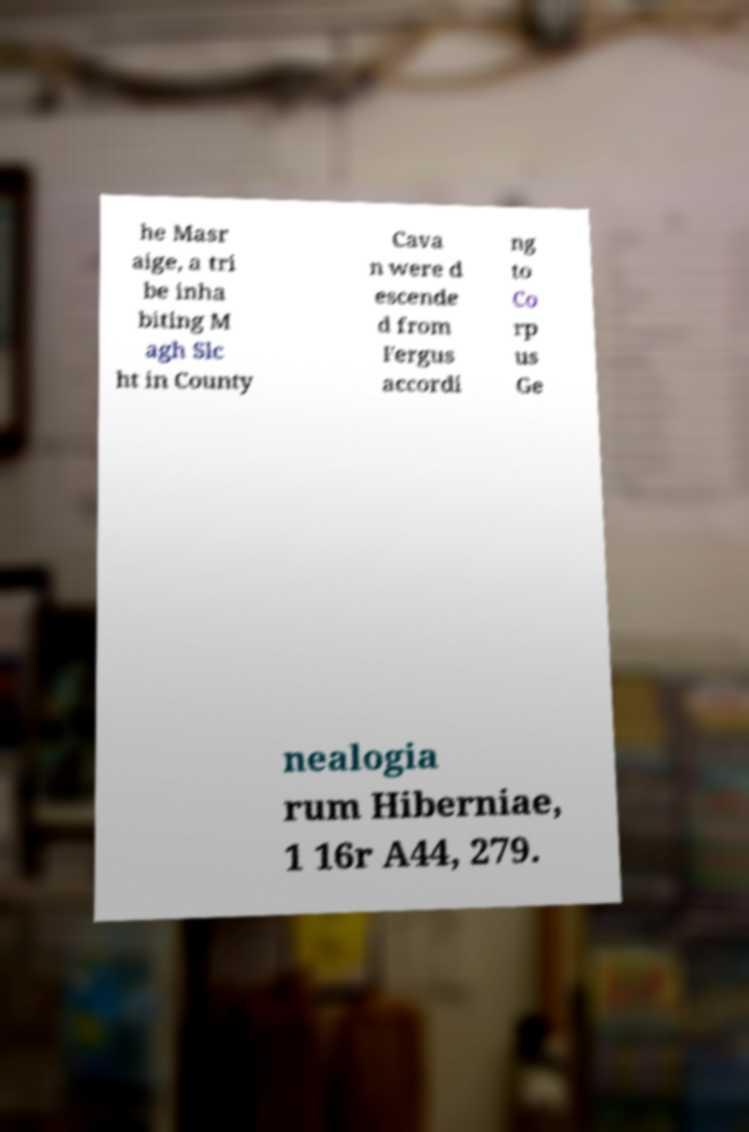Could you extract and type out the text from this image? he Masr aige, a tri be inha biting M agh Slc ht in County Cava n were d escende d from Fergus accordi ng to Co rp us Ge nealogia rum Hiberniae, 1 16r A44, 279. 